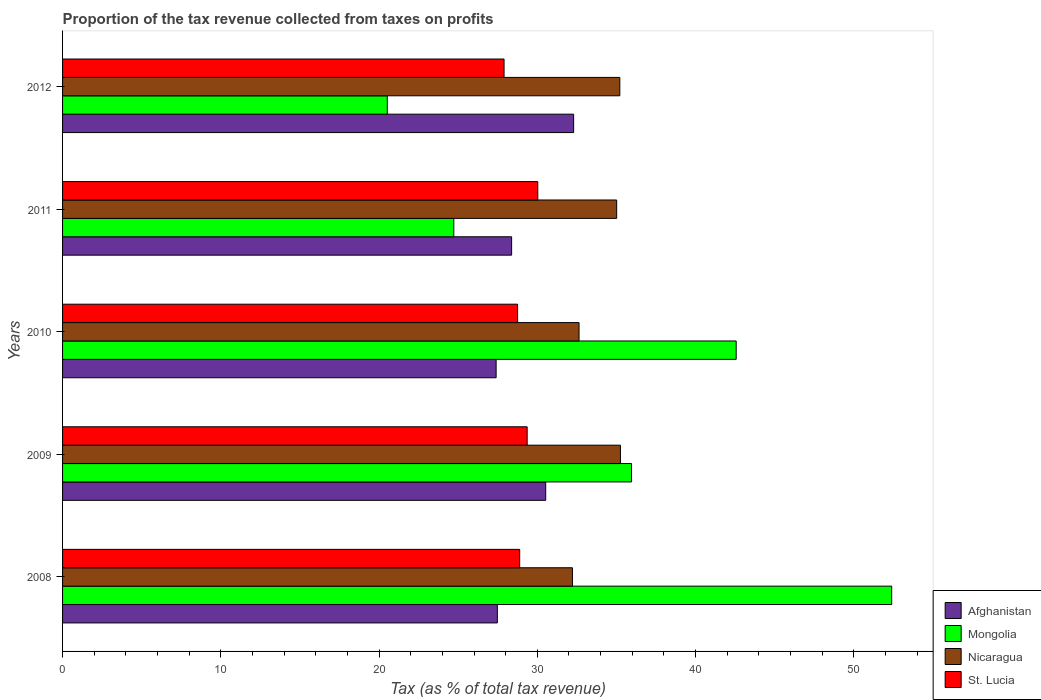How many bars are there on the 3rd tick from the bottom?
Make the answer very short. 4. What is the proportion of the tax revenue collected in Nicaragua in 2009?
Make the answer very short. 35.25. Across all years, what is the maximum proportion of the tax revenue collected in St. Lucia?
Provide a short and direct response. 30.03. Across all years, what is the minimum proportion of the tax revenue collected in Mongolia?
Ensure brevity in your answer.  20.52. In which year was the proportion of the tax revenue collected in Afghanistan maximum?
Provide a short and direct response. 2012. What is the total proportion of the tax revenue collected in Afghanistan in the graph?
Your answer should be compact. 146.08. What is the difference between the proportion of the tax revenue collected in Afghanistan in 2011 and that in 2012?
Offer a very short reply. -3.92. What is the difference between the proportion of the tax revenue collected in St. Lucia in 2010 and the proportion of the tax revenue collected in Mongolia in 2011?
Make the answer very short. 4.03. What is the average proportion of the tax revenue collected in Mongolia per year?
Give a very brief answer. 35.23. In the year 2009, what is the difference between the proportion of the tax revenue collected in Afghanistan and proportion of the tax revenue collected in Nicaragua?
Make the answer very short. -4.72. What is the ratio of the proportion of the tax revenue collected in Mongolia in 2009 to that in 2011?
Make the answer very short. 1.45. What is the difference between the highest and the second highest proportion of the tax revenue collected in St. Lucia?
Make the answer very short. 0.67. What is the difference between the highest and the lowest proportion of the tax revenue collected in St. Lucia?
Offer a terse response. 2.13. In how many years, is the proportion of the tax revenue collected in St. Lucia greater than the average proportion of the tax revenue collected in St. Lucia taken over all years?
Offer a very short reply. 2. What does the 2nd bar from the top in 2011 represents?
Provide a short and direct response. Nicaragua. What does the 4th bar from the bottom in 2011 represents?
Provide a succinct answer. St. Lucia. Is it the case that in every year, the sum of the proportion of the tax revenue collected in Mongolia and proportion of the tax revenue collected in Nicaragua is greater than the proportion of the tax revenue collected in St. Lucia?
Keep it short and to the point. Yes. Are all the bars in the graph horizontal?
Your response must be concise. Yes. What is the difference between two consecutive major ticks on the X-axis?
Offer a terse response. 10. Does the graph contain any zero values?
Offer a terse response. No. What is the title of the graph?
Give a very brief answer. Proportion of the tax revenue collected from taxes on profits. Does "Spain" appear as one of the legend labels in the graph?
Offer a terse response. No. What is the label or title of the X-axis?
Your answer should be very brief. Tax (as % of total tax revenue). What is the label or title of the Y-axis?
Your answer should be compact. Years. What is the Tax (as % of total tax revenue) in Afghanistan in 2008?
Make the answer very short. 27.48. What is the Tax (as % of total tax revenue) of Mongolia in 2008?
Your response must be concise. 52.4. What is the Tax (as % of total tax revenue) of Nicaragua in 2008?
Your answer should be compact. 32.22. What is the Tax (as % of total tax revenue) in St. Lucia in 2008?
Ensure brevity in your answer.  28.89. What is the Tax (as % of total tax revenue) in Afghanistan in 2009?
Give a very brief answer. 30.53. What is the Tax (as % of total tax revenue) in Mongolia in 2009?
Ensure brevity in your answer.  35.95. What is the Tax (as % of total tax revenue) in Nicaragua in 2009?
Provide a succinct answer. 35.25. What is the Tax (as % of total tax revenue) in St. Lucia in 2009?
Provide a succinct answer. 29.36. What is the Tax (as % of total tax revenue) of Afghanistan in 2010?
Provide a short and direct response. 27.4. What is the Tax (as % of total tax revenue) in Mongolia in 2010?
Offer a terse response. 42.57. What is the Tax (as % of total tax revenue) of Nicaragua in 2010?
Your response must be concise. 32.64. What is the Tax (as % of total tax revenue) in St. Lucia in 2010?
Your answer should be very brief. 28.76. What is the Tax (as % of total tax revenue) of Afghanistan in 2011?
Ensure brevity in your answer.  28.38. What is the Tax (as % of total tax revenue) of Mongolia in 2011?
Give a very brief answer. 24.72. What is the Tax (as % of total tax revenue) of Nicaragua in 2011?
Ensure brevity in your answer.  35.02. What is the Tax (as % of total tax revenue) of St. Lucia in 2011?
Give a very brief answer. 30.03. What is the Tax (as % of total tax revenue) in Afghanistan in 2012?
Offer a terse response. 32.3. What is the Tax (as % of total tax revenue) in Mongolia in 2012?
Your response must be concise. 20.52. What is the Tax (as % of total tax revenue) in Nicaragua in 2012?
Ensure brevity in your answer.  35.21. What is the Tax (as % of total tax revenue) of St. Lucia in 2012?
Offer a terse response. 27.9. Across all years, what is the maximum Tax (as % of total tax revenue) of Afghanistan?
Keep it short and to the point. 32.3. Across all years, what is the maximum Tax (as % of total tax revenue) in Mongolia?
Offer a terse response. 52.4. Across all years, what is the maximum Tax (as % of total tax revenue) of Nicaragua?
Provide a succinct answer. 35.25. Across all years, what is the maximum Tax (as % of total tax revenue) in St. Lucia?
Your answer should be very brief. 30.03. Across all years, what is the minimum Tax (as % of total tax revenue) of Afghanistan?
Keep it short and to the point. 27.4. Across all years, what is the minimum Tax (as % of total tax revenue) of Mongolia?
Keep it short and to the point. 20.52. Across all years, what is the minimum Tax (as % of total tax revenue) of Nicaragua?
Make the answer very short. 32.22. Across all years, what is the minimum Tax (as % of total tax revenue) of St. Lucia?
Your answer should be very brief. 27.9. What is the total Tax (as % of total tax revenue) in Afghanistan in the graph?
Give a very brief answer. 146.08. What is the total Tax (as % of total tax revenue) in Mongolia in the graph?
Offer a terse response. 176.16. What is the total Tax (as % of total tax revenue) in Nicaragua in the graph?
Provide a succinct answer. 170.34. What is the total Tax (as % of total tax revenue) in St. Lucia in the graph?
Your answer should be compact. 144.93. What is the difference between the Tax (as % of total tax revenue) in Afghanistan in 2008 and that in 2009?
Keep it short and to the point. -3.06. What is the difference between the Tax (as % of total tax revenue) of Mongolia in 2008 and that in 2009?
Give a very brief answer. 16.44. What is the difference between the Tax (as % of total tax revenue) of Nicaragua in 2008 and that in 2009?
Give a very brief answer. -3.03. What is the difference between the Tax (as % of total tax revenue) in St. Lucia in 2008 and that in 2009?
Give a very brief answer. -0.47. What is the difference between the Tax (as % of total tax revenue) in Afghanistan in 2008 and that in 2010?
Your answer should be very brief. 0.08. What is the difference between the Tax (as % of total tax revenue) of Mongolia in 2008 and that in 2010?
Provide a succinct answer. 9.83. What is the difference between the Tax (as % of total tax revenue) of Nicaragua in 2008 and that in 2010?
Offer a terse response. -0.42. What is the difference between the Tax (as % of total tax revenue) in St. Lucia in 2008 and that in 2010?
Provide a short and direct response. 0.13. What is the difference between the Tax (as % of total tax revenue) of Afghanistan in 2008 and that in 2011?
Give a very brief answer. -0.9. What is the difference between the Tax (as % of total tax revenue) of Mongolia in 2008 and that in 2011?
Your answer should be compact. 27.67. What is the difference between the Tax (as % of total tax revenue) of Nicaragua in 2008 and that in 2011?
Ensure brevity in your answer.  -2.79. What is the difference between the Tax (as % of total tax revenue) of St. Lucia in 2008 and that in 2011?
Provide a succinct answer. -1.14. What is the difference between the Tax (as % of total tax revenue) in Afghanistan in 2008 and that in 2012?
Make the answer very short. -4.82. What is the difference between the Tax (as % of total tax revenue) in Mongolia in 2008 and that in 2012?
Give a very brief answer. 31.87. What is the difference between the Tax (as % of total tax revenue) in Nicaragua in 2008 and that in 2012?
Provide a succinct answer. -2.99. What is the difference between the Tax (as % of total tax revenue) of St. Lucia in 2008 and that in 2012?
Give a very brief answer. 0.99. What is the difference between the Tax (as % of total tax revenue) in Afghanistan in 2009 and that in 2010?
Your answer should be very brief. 3.13. What is the difference between the Tax (as % of total tax revenue) of Mongolia in 2009 and that in 2010?
Your answer should be compact. -6.62. What is the difference between the Tax (as % of total tax revenue) of Nicaragua in 2009 and that in 2010?
Your answer should be compact. 2.62. What is the difference between the Tax (as % of total tax revenue) in St. Lucia in 2009 and that in 2010?
Your answer should be compact. 0.6. What is the difference between the Tax (as % of total tax revenue) of Afghanistan in 2009 and that in 2011?
Ensure brevity in your answer.  2.15. What is the difference between the Tax (as % of total tax revenue) in Mongolia in 2009 and that in 2011?
Make the answer very short. 11.23. What is the difference between the Tax (as % of total tax revenue) of Nicaragua in 2009 and that in 2011?
Make the answer very short. 0.24. What is the difference between the Tax (as % of total tax revenue) in St. Lucia in 2009 and that in 2011?
Offer a terse response. -0.67. What is the difference between the Tax (as % of total tax revenue) of Afghanistan in 2009 and that in 2012?
Your answer should be compact. -1.77. What is the difference between the Tax (as % of total tax revenue) of Mongolia in 2009 and that in 2012?
Keep it short and to the point. 15.43. What is the difference between the Tax (as % of total tax revenue) of Nicaragua in 2009 and that in 2012?
Offer a very short reply. 0.04. What is the difference between the Tax (as % of total tax revenue) of St. Lucia in 2009 and that in 2012?
Your answer should be compact. 1.46. What is the difference between the Tax (as % of total tax revenue) in Afghanistan in 2010 and that in 2011?
Offer a very short reply. -0.98. What is the difference between the Tax (as % of total tax revenue) of Mongolia in 2010 and that in 2011?
Provide a short and direct response. 17.84. What is the difference between the Tax (as % of total tax revenue) in Nicaragua in 2010 and that in 2011?
Your response must be concise. -2.38. What is the difference between the Tax (as % of total tax revenue) of St. Lucia in 2010 and that in 2011?
Make the answer very short. -1.28. What is the difference between the Tax (as % of total tax revenue) of Afghanistan in 2010 and that in 2012?
Your answer should be very brief. -4.9. What is the difference between the Tax (as % of total tax revenue) in Mongolia in 2010 and that in 2012?
Give a very brief answer. 22.05. What is the difference between the Tax (as % of total tax revenue) in Nicaragua in 2010 and that in 2012?
Offer a terse response. -2.58. What is the difference between the Tax (as % of total tax revenue) of St. Lucia in 2010 and that in 2012?
Give a very brief answer. 0.86. What is the difference between the Tax (as % of total tax revenue) of Afghanistan in 2011 and that in 2012?
Your answer should be compact. -3.92. What is the difference between the Tax (as % of total tax revenue) in Mongolia in 2011 and that in 2012?
Provide a short and direct response. 4.2. What is the difference between the Tax (as % of total tax revenue) of Nicaragua in 2011 and that in 2012?
Keep it short and to the point. -0.2. What is the difference between the Tax (as % of total tax revenue) in St. Lucia in 2011 and that in 2012?
Give a very brief answer. 2.13. What is the difference between the Tax (as % of total tax revenue) in Afghanistan in 2008 and the Tax (as % of total tax revenue) in Mongolia in 2009?
Ensure brevity in your answer.  -8.48. What is the difference between the Tax (as % of total tax revenue) of Afghanistan in 2008 and the Tax (as % of total tax revenue) of Nicaragua in 2009?
Offer a terse response. -7.78. What is the difference between the Tax (as % of total tax revenue) in Afghanistan in 2008 and the Tax (as % of total tax revenue) in St. Lucia in 2009?
Your answer should be very brief. -1.88. What is the difference between the Tax (as % of total tax revenue) in Mongolia in 2008 and the Tax (as % of total tax revenue) in Nicaragua in 2009?
Give a very brief answer. 17.14. What is the difference between the Tax (as % of total tax revenue) in Mongolia in 2008 and the Tax (as % of total tax revenue) in St. Lucia in 2009?
Provide a short and direct response. 23.04. What is the difference between the Tax (as % of total tax revenue) in Nicaragua in 2008 and the Tax (as % of total tax revenue) in St. Lucia in 2009?
Provide a short and direct response. 2.86. What is the difference between the Tax (as % of total tax revenue) of Afghanistan in 2008 and the Tax (as % of total tax revenue) of Mongolia in 2010?
Provide a short and direct response. -15.09. What is the difference between the Tax (as % of total tax revenue) of Afghanistan in 2008 and the Tax (as % of total tax revenue) of Nicaragua in 2010?
Offer a very short reply. -5.16. What is the difference between the Tax (as % of total tax revenue) of Afghanistan in 2008 and the Tax (as % of total tax revenue) of St. Lucia in 2010?
Your answer should be very brief. -1.28. What is the difference between the Tax (as % of total tax revenue) in Mongolia in 2008 and the Tax (as % of total tax revenue) in Nicaragua in 2010?
Make the answer very short. 19.76. What is the difference between the Tax (as % of total tax revenue) of Mongolia in 2008 and the Tax (as % of total tax revenue) of St. Lucia in 2010?
Keep it short and to the point. 23.64. What is the difference between the Tax (as % of total tax revenue) in Nicaragua in 2008 and the Tax (as % of total tax revenue) in St. Lucia in 2010?
Give a very brief answer. 3.47. What is the difference between the Tax (as % of total tax revenue) of Afghanistan in 2008 and the Tax (as % of total tax revenue) of Mongolia in 2011?
Ensure brevity in your answer.  2.75. What is the difference between the Tax (as % of total tax revenue) in Afghanistan in 2008 and the Tax (as % of total tax revenue) in Nicaragua in 2011?
Ensure brevity in your answer.  -7.54. What is the difference between the Tax (as % of total tax revenue) of Afghanistan in 2008 and the Tax (as % of total tax revenue) of St. Lucia in 2011?
Give a very brief answer. -2.56. What is the difference between the Tax (as % of total tax revenue) in Mongolia in 2008 and the Tax (as % of total tax revenue) in Nicaragua in 2011?
Keep it short and to the point. 17.38. What is the difference between the Tax (as % of total tax revenue) in Mongolia in 2008 and the Tax (as % of total tax revenue) in St. Lucia in 2011?
Make the answer very short. 22.37. What is the difference between the Tax (as % of total tax revenue) of Nicaragua in 2008 and the Tax (as % of total tax revenue) of St. Lucia in 2011?
Provide a short and direct response. 2.19. What is the difference between the Tax (as % of total tax revenue) of Afghanistan in 2008 and the Tax (as % of total tax revenue) of Mongolia in 2012?
Ensure brevity in your answer.  6.95. What is the difference between the Tax (as % of total tax revenue) in Afghanistan in 2008 and the Tax (as % of total tax revenue) in Nicaragua in 2012?
Your answer should be very brief. -7.74. What is the difference between the Tax (as % of total tax revenue) of Afghanistan in 2008 and the Tax (as % of total tax revenue) of St. Lucia in 2012?
Offer a terse response. -0.42. What is the difference between the Tax (as % of total tax revenue) of Mongolia in 2008 and the Tax (as % of total tax revenue) of Nicaragua in 2012?
Provide a short and direct response. 17.18. What is the difference between the Tax (as % of total tax revenue) in Mongolia in 2008 and the Tax (as % of total tax revenue) in St. Lucia in 2012?
Offer a terse response. 24.5. What is the difference between the Tax (as % of total tax revenue) of Nicaragua in 2008 and the Tax (as % of total tax revenue) of St. Lucia in 2012?
Ensure brevity in your answer.  4.32. What is the difference between the Tax (as % of total tax revenue) in Afghanistan in 2009 and the Tax (as % of total tax revenue) in Mongolia in 2010?
Your response must be concise. -12.04. What is the difference between the Tax (as % of total tax revenue) in Afghanistan in 2009 and the Tax (as % of total tax revenue) in Nicaragua in 2010?
Make the answer very short. -2.11. What is the difference between the Tax (as % of total tax revenue) of Afghanistan in 2009 and the Tax (as % of total tax revenue) of St. Lucia in 2010?
Give a very brief answer. 1.78. What is the difference between the Tax (as % of total tax revenue) in Mongolia in 2009 and the Tax (as % of total tax revenue) in Nicaragua in 2010?
Give a very brief answer. 3.31. What is the difference between the Tax (as % of total tax revenue) of Mongolia in 2009 and the Tax (as % of total tax revenue) of St. Lucia in 2010?
Make the answer very short. 7.2. What is the difference between the Tax (as % of total tax revenue) of Nicaragua in 2009 and the Tax (as % of total tax revenue) of St. Lucia in 2010?
Ensure brevity in your answer.  6.5. What is the difference between the Tax (as % of total tax revenue) in Afghanistan in 2009 and the Tax (as % of total tax revenue) in Mongolia in 2011?
Your response must be concise. 5.81. What is the difference between the Tax (as % of total tax revenue) of Afghanistan in 2009 and the Tax (as % of total tax revenue) of Nicaragua in 2011?
Offer a terse response. -4.48. What is the difference between the Tax (as % of total tax revenue) in Afghanistan in 2009 and the Tax (as % of total tax revenue) in St. Lucia in 2011?
Make the answer very short. 0.5. What is the difference between the Tax (as % of total tax revenue) of Mongolia in 2009 and the Tax (as % of total tax revenue) of Nicaragua in 2011?
Make the answer very short. 0.94. What is the difference between the Tax (as % of total tax revenue) in Mongolia in 2009 and the Tax (as % of total tax revenue) in St. Lucia in 2011?
Provide a short and direct response. 5.92. What is the difference between the Tax (as % of total tax revenue) in Nicaragua in 2009 and the Tax (as % of total tax revenue) in St. Lucia in 2011?
Give a very brief answer. 5.22. What is the difference between the Tax (as % of total tax revenue) of Afghanistan in 2009 and the Tax (as % of total tax revenue) of Mongolia in 2012?
Give a very brief answer. 10.01. What is the difference between the Tax (as % of total tax revenue) of Afghanistan in 2009 and the Tax (as % of total tax revenue) of Nicaragua in 2012?
Offer a terse response. -4.68. What is the difference between the Tax (as % of total tax revenue) in Afghanistan in 2009 and the Tax (as % of total tax revenue) in St. Lucia in 2012?
Provide a short and direct response. 2.63. What is the difference between the Tax (as % of total tax revenue) in Mongolia in 2009 and the Tax (as % of total tax revenue) in Nicaragua in 2012?
Make the answer very short. 0.74. What is the difference between the Tax (as % of total tax revenue) in Mongolia in 2009 and the Tax (as % of total tax revenue) in St. Lucia in 2012?
Your answer should be compact. 8.05. What is the difference between the Tax (as % of total tax revenue) of Nicaragua in 2009 and the Tax (as % of total tax revenue) of St. Lucia in 2012?
Your answer should be very brief. 7.35. What is the difference between the Tax (as % of total tax revenue) in Afghanistan in 2010 and the Tax (as % of total tax revenue) in Mongolia in 2011?
Offer a very short reply. 2.67. What is the difference between the Tax (as % of total tax revenue) of Afghanistan in 2010 and the Tax (as % of total tax revenue) of Nicaragua in 2011?
Provide a succinct answer. -7.62. What is the difference between the Tax (as % of total tax revenue) of Afghanistan in 2010 and the Tax (as % of total tax revenue) of St. Lucia in 2011?
Provide a short and direct response. -2.63. What is the difference between the Tax (as % of total tax revenue) of Mongolia in 2010 and the Tax (as % of total tax revenue) of Nicaragua in 2011?
Your response must be concise. 7.55. What is the difference between the Tax (as % of total tax revenue) of Mongolia in 2010 and the Tax (as % of total tax revenue) of St. Lucia in 2011?
Offer a very short reply. 12.54. What is the difference between the Tax (as % of total tax revenue) in Nicaragua in 2010 and the Tax (as % of total tax revenue) in St. Lucia in 2011?
Provide a succinct answer. 2.61. What is the difference between the Tax (as % of total tax revenue) in Afghanistan in 2010 and the Tax (as % of total tax revenue) in Mongolia in 2012?
Provide a short and direct response. 6.88. What is the difference between the Tax (as % of total tax revenue) in Afghanistan in 2010 and the Tax (as % of total tax revenue) in Nicaragua in 2012?
Provide a short and direct response. -7.82. What is the difference between the Tax (as % of total tax revenue) in Afghanistan in 2010 and the Tax (as % of total tax revenue) in St. Lucia in 2012?
Keep it short and to the point. -0.5. What is the difference between the Tax (as % of total tax revenue) in Mongolia in 2010 and the Tax (as % of total tax revenue) in Nicaragua in 2012?
Your answer should be compact. 7.35. What is the difference between the Tax (as % of total tax revenue) of Mongolia in 2010 and the Tax (as % of total tax revenue) of St. Lucia in 2012?
Offer a terse response. 14.67. What is the difference between the Tax (as % of total tax revenue) of Nicaragua in 2010 and the Tax (as % of total tax revenue) of St. Lucia in 2012?
Your answer should be compact. 4.74. What is the difference between the Tax (as % of total tax revenue) in Afghanistan in 2011 and the Tax (as % of total tax revenue) in Mongolia in 2012?
Give a very brief answer. 7.86. What is the difference between the Tax (as % of total tax revenue) in Afghanistan in 2011 and the Tax (as % of total tax revenue) in Nicaragua in 2012?
Keep it short and to the point. -6.84. What is the difference between the Tax (as % of total tax revenue) in Afghanistan in 2011 and the Tax (as % of total tax revenue) in St. Lucia in 2012?
Make the answer very short. 0.48. What is the difference between the Tax (as % of total tax revenue) in Mongolia in 2011 and the Tax (as % of total tax revenue) in Nicaragua in 2012?
Your answer should be compact. -10.49. What is the difference between the Tax (as % of total tax revenue) in Mongolia in 2011 and the Tax (as % of total tax revenue) in St. Lucia in 2012?
Offer a terse response. -3.18. What is the difference between the Tax (as % of total tax revenue) of Nicaragua in 2011 and the Tax (as % of total tax revenue) of St. Lucia in 2012?
Your answer should be very brief. 7.12. What is the average Tax (as % of total tax revenue) of Afghanistan per year?
Provide a short and direct response. 29.22. What is the average Tax (as % of total tax revenue) of Mongolia per year?
Ensure brevity in your answer.  35.23. What is the average Tax (as % of total tax revenue) of Nicaragua per year?
Ensure brevity in your answer.  34.07. What is the average Tax (as % of total tax revenue) in St. Lucia per year?
Give a very brief answer. 28.99. In the year 2008, what is the difference between the Tax (as % of total tax revenue) of Afghanistan and Tax (as % of total tax revenue) of Mongolia?
Your answer should be compact. -24.92. In the year 2008, what is the difference between the Tax (as % of total tax revenue) of Afghanistan and Tax (as % of total tax revenue) of Nicaragua?
Give a very brief answer. -4.75. In the year 2008, what is the difference between the Tax (as % of total tax revenue) of Afghanistan and Tax (as % of total tax revenue) of St. Lucia?
Ensure brevity in your answer.  -1.41. In the year 2008, what is the difference between the Tax (as % of total tax revenue) of Mongolia and Tax (as % of total tax revenue) of Nicaragua?
Give a very brief answer. 20.17. In the year 2008, what is the difference between the Tax (as % of total tax revenue) in Mongolia and Tax (as % of total tax revenue) in St. Lucia?
Provide a succinct answer. 23.51. In the year 2008, what is the difference between the Tax (as % of total tax revenue) in Nicaragua and Tax (as % of total tax revenue) in St. Lucia?
Offer a terse response. 3.33. In the year 2009, what is the difference between the Tax (as % of total tax revenue) of Afghanistan and Tax (as % of total tax revenue) of Mongolia?
Your response must be concise. -5.42. In the year 2009, what is the difference between the Tax (as % of total tax revenue) of Afghanistan and Tax (as % of total tax revenue) of Nicaragua?
Your answer should be very brief. -4.72. In the year 2009, what is the difference between the Tax (as % of total tax revenue) in Afghanistan and Tax (as % of total tax revenue) in St. Lucia?
Your answer should be very brief. 1.17. In the year 2009, what is the difference between the Tax (as % of total tax revenue) in Mongolia and Tax (as % of total tax revenue) in Nicaragua?
Provide a succinct answer. 0.7. In the year 2009, what is the difference between the Tax (as % of total tax revenue) in Mongolia and Tax (as % of total tax revenue) in St. Lucia?
Your answer should be very brief. 6.59. In the year 2009, what is the difference between the Tax (as % of total tax revenue) of Nicaragua and Tax (as % of total tax revenue) of St. Lucia?
Your answer should be compact. 5.9. In the year 2010, what is the difference between the Tax (as % of total tax revenue) in Afghanistan and Tax (as % of total tax revenue) in Mongolia?
Provide a succinct answer. -15.17. In the year 2010, what is the difference between the Tax (as % of total tax revenue) of Afghanistan and Tax (as % of total tax revenue) of Nicaragua?
Offer a very short reply. -5.24. In the year 2010, what is the difference between the Tax (as % of total tax revenue) in Afghanistan and Tax (as % of total tax revenue) in St. Lucia?
Provide a short and direct response. -1.36. In the year 2010, what is the difference between the Tax (as % of total tax revenue) of Mongolia and Tax (as % of total tax revenue) of Nicaragua?
Your answer should be compact. 9.93. In the year 2010, what is the difference between the Tax (as % of total tax revenue) in Mongolia and Tax (as % of total tax revenue) in St. Lucia?
Your response must be concise. 13.81. In the year 2010, what is the difference between the Tax (as % of total tax revenue) in Nicaragua and Tax (as % of total tax revenue) in St. Lucia?
Provide a succinct answer. 3.88. In the year 2011, what is the difference between the Tax (as % of total tax revenue) in Afghanistan and Tax (as % of total tax revenue) in Mongolia?
Provide a succinct answer. 3.65. In the year 2011, what is the difference between the Tax (as % of total tax revenue) of Afghanistan and Tax (as % of total tax revenue) of Nicaragua?
Provide a short and direct response. -6.64. In the year 2011, what is the difference between the Tax (as % of total tax revenue) in Afghanistan and Tax (as % of total tax revenue) in St. Lucia?
Your answer should be compact. -1.65. In the year 2011, what is the difference between the Tax (as % of total tax revenue) in Mongolia and Tax (as % of total tax revenue) in Nicaragua?
Give a very brief answer. -10.29. In the year 2011, what is the difference between the Tax (as % of total tax revenue) of Mongolia and Tax (as % of total tax revenue) of St. Lucia?
Your response must be concise. -5.31. In the year 2011, what is the difference between the Tax (as % of total tax revenue) in Nicaragua and Tax (as % of total tax revenue) in St. Lucia?
Make the answer very short. 4.99. In the year 2012, what is the difference between the Tax (as % of total tax revenue) of Afghanistan and Tax (as % of total tax revenue) of Mongolia?
Your answer should be compact. 11.78. In the year 2012, what is the difference between the Tax (as % of total tax revenue) in Afghanistan and Tax (as % of total tax revenue) in Nicaragua?
Keep it short and to the point. -2.92. In the year 2012, what is the difference between the Tax (as % of total tax revenue) in Afghanistan and Tax (as % of total tax revenue) in St. Lucia?
Offer a terse response. 4.4. In the year 2012, what is the difference between the Tax (as % of total tax revenue) in Mongolia and Tax (as % of total tax revenue) in Nicaragua?
Offer a terse response. -14.69. In the year 2012, what is the difference between the Tax (as % of total tax revenue) in Mongolia and Tax (as % of total tax revenue) in St. Lucia?
Give a very brief answer. -7.38. In the year 2012, what is the difference between the Tax (as % of total tax revenue) in Nicaragua and Tax (as % of total tax revenue) in St. Lucia?
Provide a short and direct response. 7.31. What is the ratio of the Tax (as % of total tax revenue) in Afghanistan in 2008 to that in 2009?
Your answer should be compact. 0.9. What is the ratio of the Tax (as % of total tax revenue) of Mongolia in 2008 to that in 2009?
Your response must be concise. 1.46. What is the ratio of the Tax (as % of total tax revenue) in Nicaragua in 2008 to that in 2009?
Make the answer very short. 0.91. What is the ratio of the Tax (as % of total tax revenue) of St. Lucia in 2008 to that in 2009?
Make the answer very short. 0.98. What is the ratio of the Tax (as % of total tax revenue) of Mongolia in 2008 to that in 2010?
Offer a very short reply. 1.23. What is the ratio of the Tax (as % of total tax revenue) of Nicaragua in 2008 to that in 2010?
Provide a succinct answer. 0.99. What is the ratio of the Tax (as % of total tax revenue) of Afghanistan in 2008 to that in 2011?
Your answer should be compact. 0.97. What is the ratio of the Tax (as % of total tax revenue) of Mongolia in 2008 to that in 2011?
Your answer should be very brief. 2.12. What is the ratio of the Tax (as % of total tax revenue) of Nicaragua in 2008 to that in 2011?
Offer a very short reply. 0.92. What is the ratio of the Tax (as % of total tax revenue) of St. Lucia in 2008 to that in 2011?
Ensure brevity in your answer.  0.96. What is the ratio of the Tax (as % of total tax revenue) of Afghanistan in 2008 to that in 2012?
Offer a very short reply. 0.85. What is the ratio of the Tax (as % of total tax revenue) of Mongolia in 2008 to that in 2012?
Offer a very short reply. 2.55. What is the ratio of the Tax (as % of total tax revenue) of Nicaragua in 2008 to that in 2012?
Offer a very short reply. 0.92. What is the ratio of the Tax (as % of total tax revenue) of St. Lucia in 2008 to that in 2012?
Your response must be concise. 1.04. What is the ratio of the Tax (as % of total tax revenue) of Afghanistan in 2009 to that in 2010?
Give a very brief answer. 1.11. What is the ratio of the Tax (as % of total tax revenue) in Mongolia in 2009 to that in 2010?
Keep it short and to the point. 0.84. What is the ratio of the Tax (as % of total tax revenue) in Nicaragua in 2009 to that in 2010?
Keep it short and to the point. 1.08. What is the ratio of the Tax (as % of total tax revenue) in Afghanistan in 2009 to that in 2011?
Your response must be concise. 1.08. What is the ratio of the Tax (as % of total tax revenue) of Mongolia in 2009 to that in 2011?
Your answer should be very brief. 1.45. What is the ratio of the Tax (as % of total tax revenue) of Nicaragua in 2009 to that in 2011?
Give a very brief answer. 1.01. What is the ratio of the Tax (as % of total tax revenue) of St. Lucia in 2009 to that in 2011?
Your response must be concise. 0.98. What is the ratio of the Tax (as % of total tax revenue) in Afghanistan in 2009 to that in 2012?
Provide a succinct answer. 0.95. What is the ratio of the Tax (as % of total tax revenue) of Mongolia in 2009 to that in 2012?
Offer a terse response. 1.75. What is the ratio of the Tax (as % of total tax revenue) of St. Lucia in 2009 to that in 2012?
Make the answer very short. 1.05. What is the ratio of the Tax (as % of total tax revenue) of Afghanistan in 2010 to that in 2011?
Make the answer very short. 0.97. What is the ratio of the Tax (as % of total tax revenue) in Mongolia in 2010 to that in 2011?
Ensure brevity in your answer.  1.72. What is the ratio of the Tax (as % of total tax revenue) in Nicaragua in 2010 to that in 2011?
Your response must be concise. 0.93. What is the ratio of the Tax (as % of total tax revenue) in St. Lucia in 2010 to that in 2011?
Your answer should be very brief. 0.96. What is the ratio of the Tax (as % of total tax revenue) in Afghanistan in 2010 to that in 2012?
Your response must be concise. 0.85. What is the ratio of the Tax (as % of total tax revenue) in Mongolia in 2010 to that in 2012?
Ensure brevity in your answer.  2.07. What is the ratio of the Tax (as % of total tax revenue) in Nicaragua in 2010 to that in 2012?
Your answer should be very brief. 0.93. What is the ratio of the Tax (as % of total tax revenue) in St. Lucia in 2010 to that in 2012?
Offer a terse response. 1.03. What is the ratio of the Tax (as % of total tax revenue) in Afghanistan in 2011 to that in 2012?
Ensure brevity in your answer.  0.88. What is the ratio of the Tax (as % of total tax revenue) in Mongolia in 2011 to that in 2012?
Provide a succinct answer. 1.2. What is the ratio of the Tax (as % of total tax revenue) in St. Lucia in 2011 to that in 2012?
Your answer should be compact. 1.08. What is the difference between the highest and the second highest Tax (as % of total tax revenue) of Afghanistan?
Give a very brief answer. 1.77. What is the difference between the highest and the second highest Tax (as % of total tax revenue) of Mongolia?
Provide a succinct answer. 9.83. What is the difference between the highest and the second highest Tax (as % of total tax revenue) in Nicaragua?
Make the answer very short. 0.04. What is the difference between the highest and the second highest Tax (as % of total tax revenue) of St. Lucia?
Ensure brevity in your answer.  0.67. What is the difference between the highest and the lowest Tax (as % of total tax revenue) in Afghanistan?
Your answer should be very brief. 4.9. What is the difference between the highest and the lowest Tax (as % of total tax revenue) of Mongolia?
Your answer should be compact. 31.87. What is the difference between the highest and the lowest Tax (as % of total tax revenue) in Nicaragua?
Your answer should be compact. 3.03. What is the difference between the highest and the lowest Tax (as % of total tax revenue) of St. Lucia?
Offer a terse response. 2.13. 